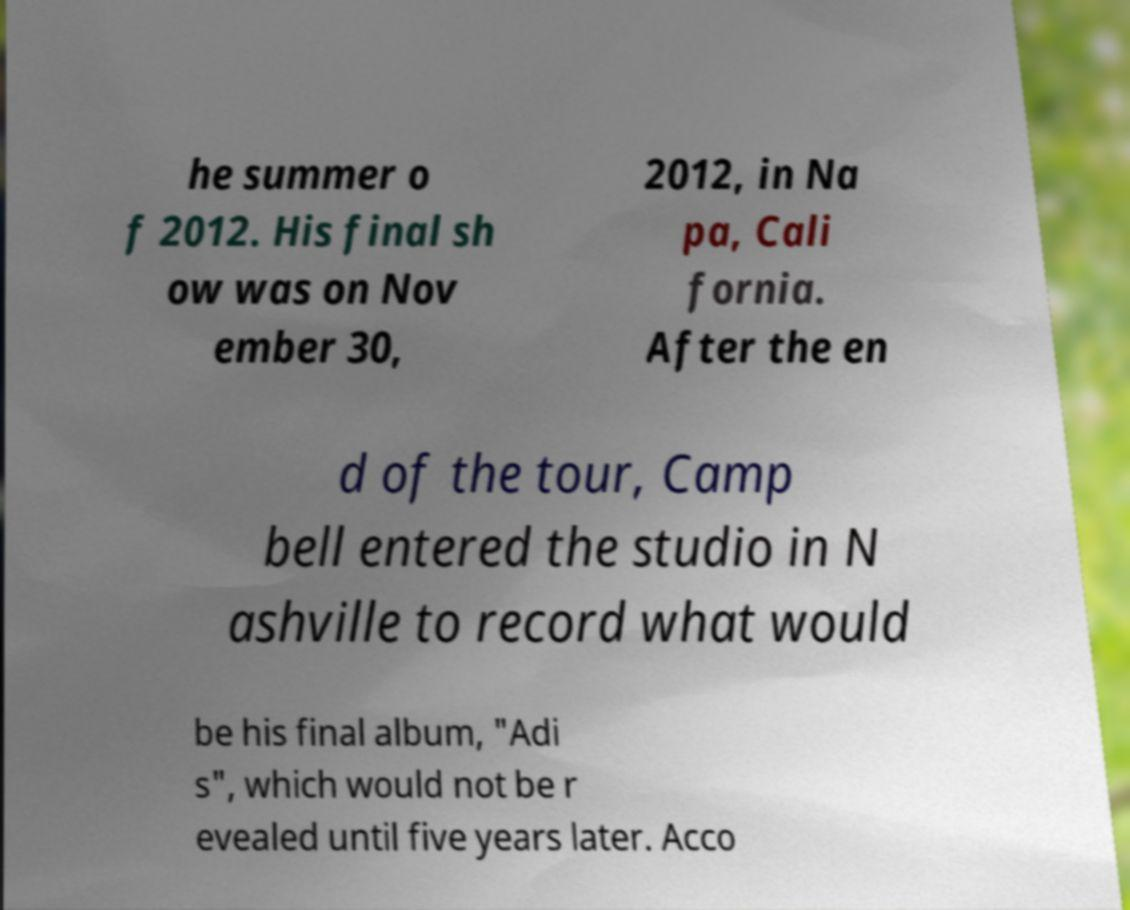Could you assist in decoding the text presented in this image and type it out clearly? he summer o f 2012. His final sh ow was on Nov ember 30, 2012, in Na pa, Cali fornia. After the en d of the tour, Camp bell entered the studio in N ashville to record what would be his final album, "Adi s", which would not be r evealed until five years later. Acco 